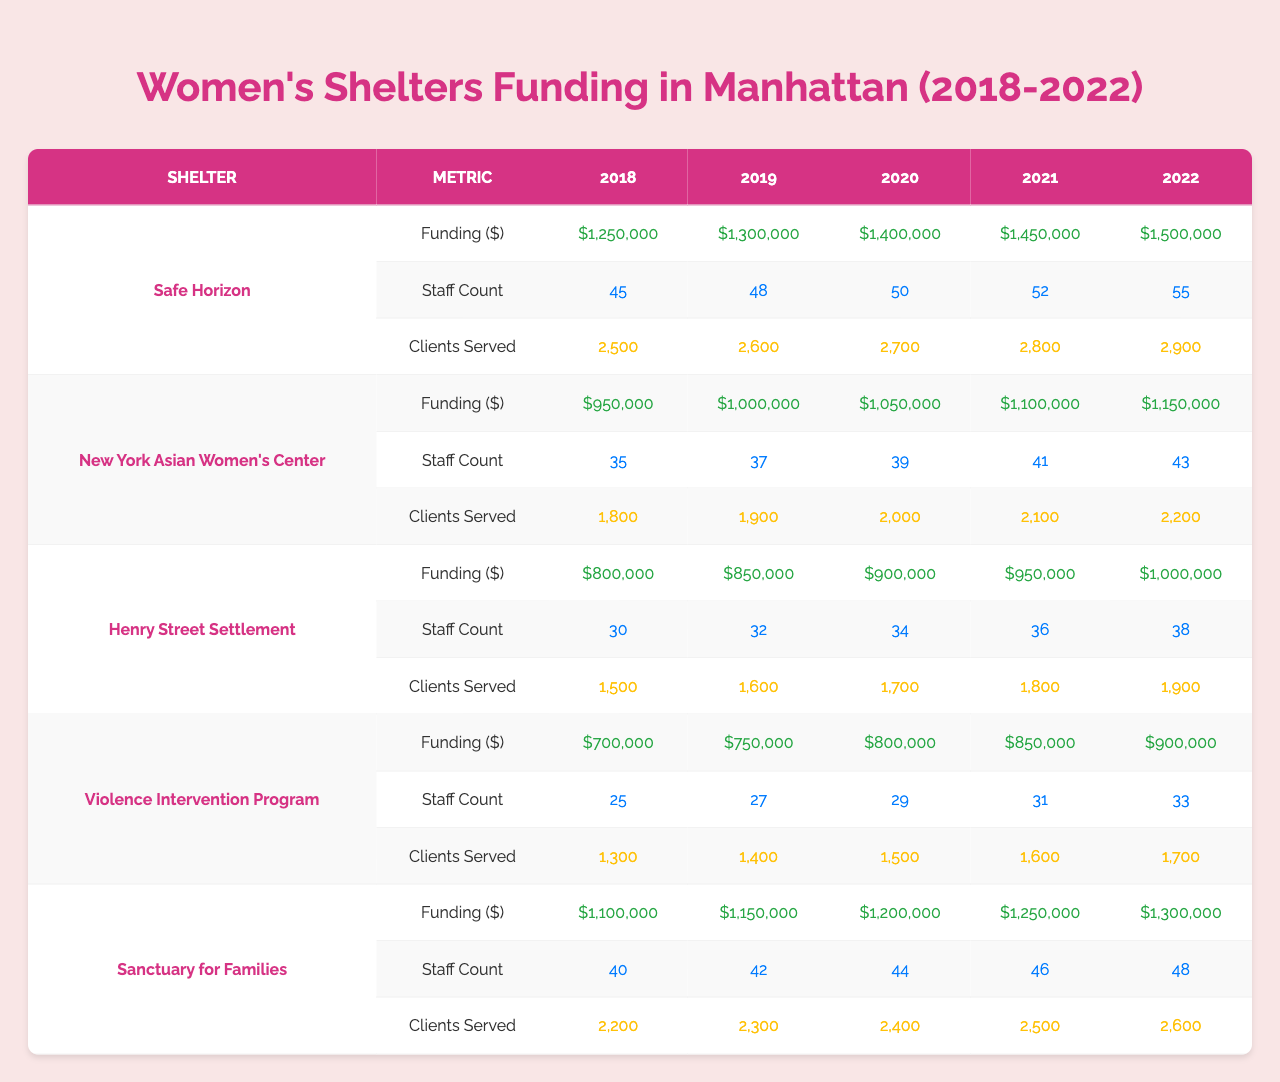What was the funding amount for Safe Horizon in 2022? The table shows that Safe Horizon received $1,500,000 in funding for the year 2022.
Answer: $1,500,000 How many clients were served by the New York Asian Women's Center in 2020? According to the table, the New York Asian Women's Center served 2,000 clients in 2020.
Answer: 2,000 Which shelter had the highest funding in 2019? From the table, Safe Horizon had the highest funding in 2019, which was $1,300,000.
Answer: Safe Horizon What is the total funding received by Sanctuary for Families over the 5 years? The total funding for Sanctuary for Families is calculated by adding the yearly amounts: $1,100,000 + $1,150,000 + $1,200,000 + $1,250,000 + $1,300,000 = $6,000,000.
Answer: $6,000,000 Did the Violence Intervention Program’s funding increase every year? By comparing the funding amounts from the table, we see that the funding increased from $700,000 in 2018 to $900,000 in 2022, which confirms an increase each year.
Answer: Yes What is the average number of clients served by Henry Street Settlement over the 5 years? The number of clients served by Henry Street Settlement are 1,500, 1,600, 1,700, 1,800, and 1,900. The total is 1,500 + 1,600 + 1,700 + 1,800 + 1,900 = 8,500. The average is 8,500 divided by 5, which equals 1,700.
Answer: 1,700 Which shelter has the highest number of staff in 2021? In 2021, the staff counts were: Safe Horizon (52), New York Asian Women's Center (41), Henry Street Settlement (36), Violence Intervention Program (31), and Sanctuary for Families (46). Thus, Safe Horizon has the highest count with 52 staff.
Answer: Safe Horizon What is the percentage increase in funding for Safe Horizon from 2018 to 2022? The funding for Safe Horizon in 2018 was $1,250,000, and in 2022, it was $1,500,000. The difference is $1,500,000 - $1,250,000 = $250,000. To find the percentage increase, we divide the increase by the original funding: ($250,000 / $1,250,000) * 100 = 20%.
Answer: 20% How many more clients were served by Sanctuary for Families in 2022 compared to 2018? Sanctuary for Families served 2,600 clients in 2022 and 2,200 clients in 2018. The difference is 2,600 - 2,200 = 400 clients.
Answer: 400 clients What was the total staff count for all shelters combined in 2019? The staff counts in 2019 were: Safe Horizon (48), New York Asian Women's Center (37), Henry Street Settlement (32), Violence Intervention Program (27), and Sanctuary for Families (42). The total is 48 + 37 + 32 + 27 + 42 = 186.
Answer: 186 